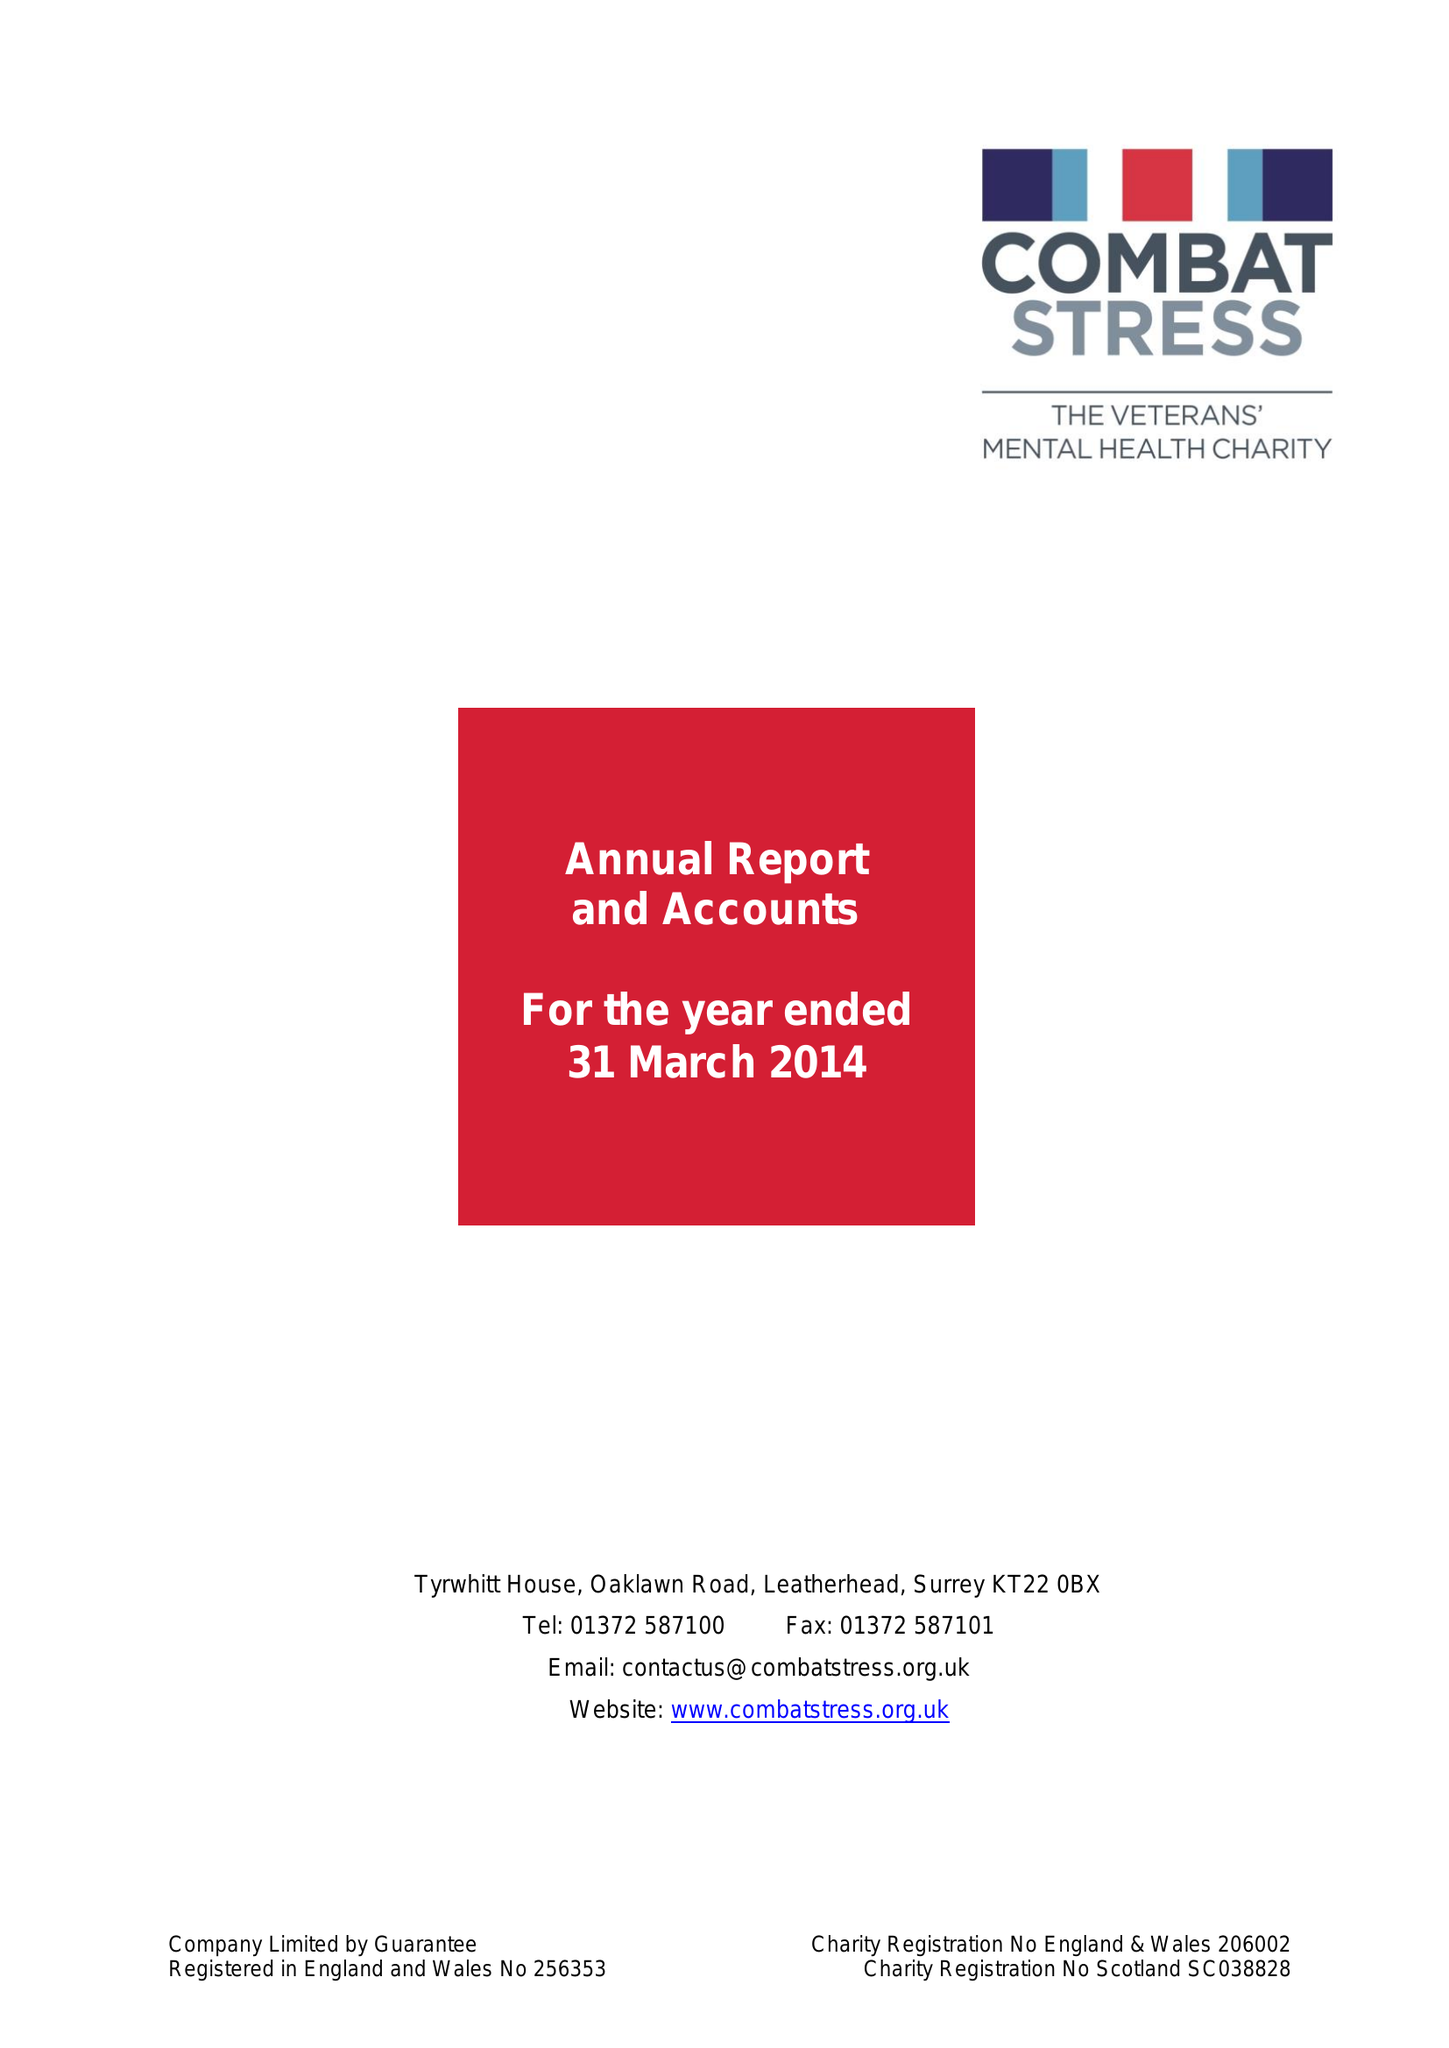What is the value for the report_date?
Answer the question using a single word or phrase. 2014-03-31 